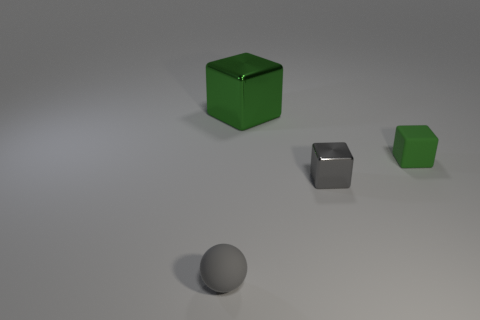Is the number of small gray things less than the number of objects?
Offer a terse response. Yes. What is the material of the gray sphere in front of the shiny cube that is behind the gray shiny object that is behind the gray matte object?
Provide a succinct answer. Rubber. What is the material of the tiny green block?
Your answer should be very brief. Rubber. There is a metallic object on the right side of the large shiny thing; is it the same color as the small rubber object left of the small metal block?
Your response must be concise. Yes. Are there more blue shiny balls than gray balls?
Give a very brief answer. No. What number of objects are the same color as the matte sphere?
Offer a very short reply. 1. There is a big metal object that is the same shape as the small green object; what is its color?
Your answer should be compact. Green. What is the material of the block that is both to the left of the small green thing and behind the gray cube?
Your response must be concise. Metal. Are the green thing in front of the large block and the gray object that is behind the small gray rubber sphere made of the same material?
Ensure brevity in your answer.  No. What size is the green shiny block?
Give a very brief answer. Large. 